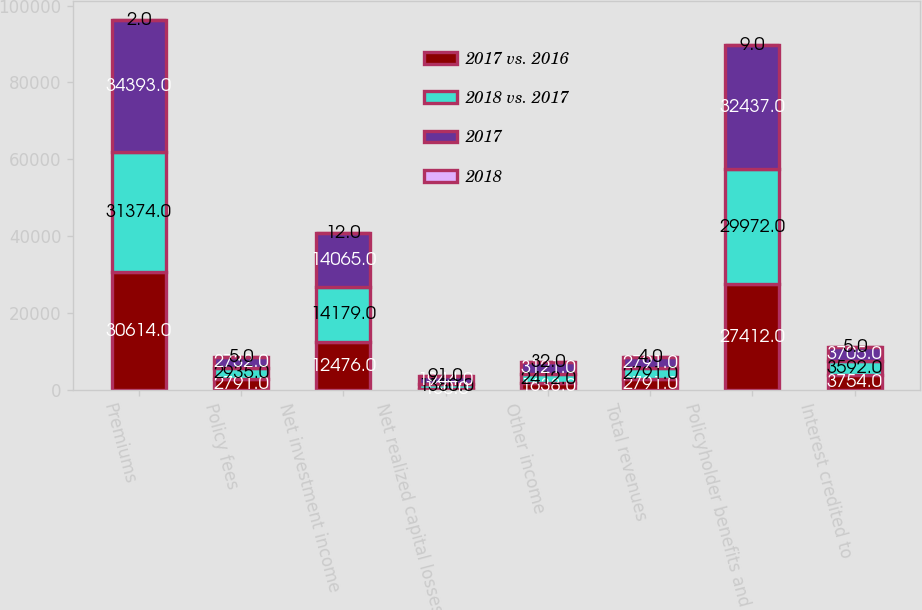Convert chart to OTSL. <chart><loc_0><loc_0><loc_500><loc_500><stacked_bar_chart><ecel><fcel>Premiums<fcel>Policy fees<fcel>Net investment income<fcel>Net realized capital losses<fcel>Other income<fcel>Total revenues<fcel>Policyholder benefits and<fcel>Interest credited to<nl><fcel>2017 vs. 2016<fcel>30614<fcel>2791<fcel>12476<fcel>130<fcel>1638<fcel>2791<fcel>27412<fcel>3754<nl><fcel>2018 vs. 2017<fcel>31374<fcel>2935<fcel>14179<fcel>1380<fcel>2412<fcel>2791<fcel>29972<fcel>3592<nl><fcel>2017<fcel>34393<fcel>2732<fcel>14065<fcel>1944<fcel>3121<fcel>2791<fcel>32437<fcel>3705<nl><fcel>2018<fcel>2<fcel>5<fcel>12<fcel>91<fcel>32<fcel>4<fcel>9<fcel>5<nl></chart> 